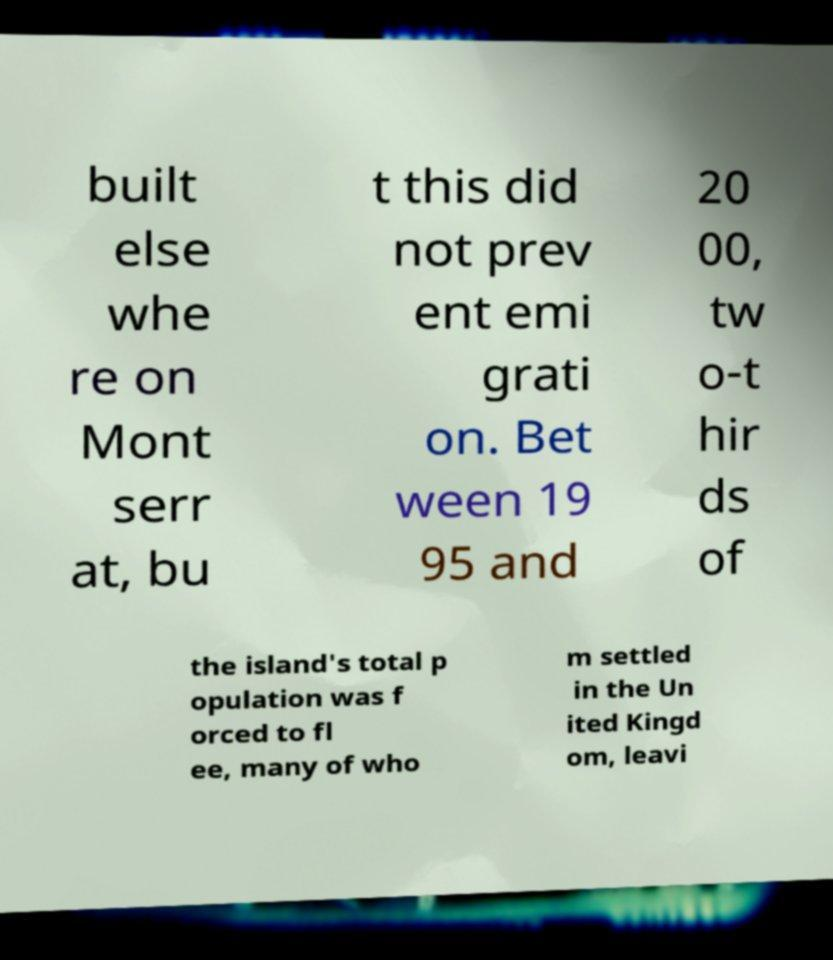For documentation purposes, I need the text within this image transcribed. Could you provide that? built else whe re on Mont serr at, bu t this did not prev ent emi grati on. Bet ween 19 95 and 20 00, tw o-t hir ds of the island's total p opulation was f orced to fl ee, many of who m settled in the Un ited Kingd om, leavi 